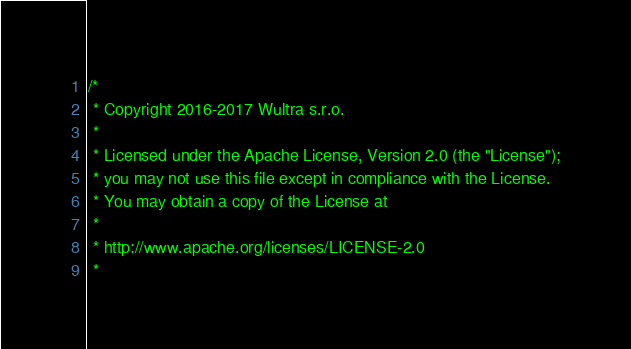Convert code to text. <code><loc_0><loc_0><loc_500><loc_500><_ObjectiveC_>/*
 * Copyright 2016-2017 Wultra s.r.o.
 *
 * Licensed under the Apache License, Version 2.0 (the "License");
 * you may not use this file except in compliance with the License.
 * You may obtain a copy of the License at
 *
 * http://www.apache.org/licenses/LICENSE-2.0
 *</code> 